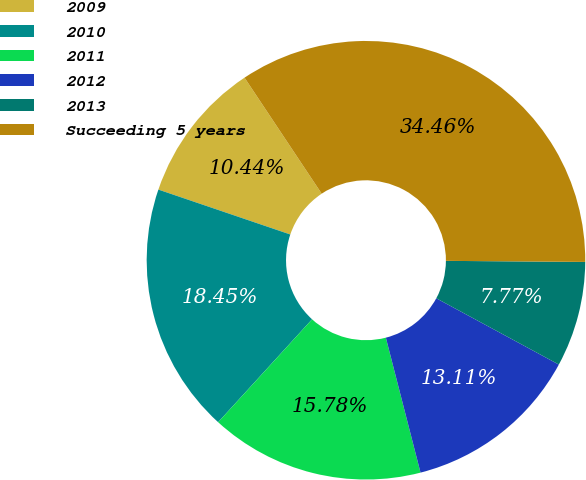<chart> <loc_0><loc_0><loc_500><loc_500><pie_chart><fcel>2009<fcel>2010<fcel>2011<fcel>2012<fcel>2013<fcel>Succeeding 5 years<nl><fcel>10.44%<fcel>18.45%<fcel>15.78%<fcel>13.11%<fcel>7.77%<fcel>34.47%<nl></chart> 